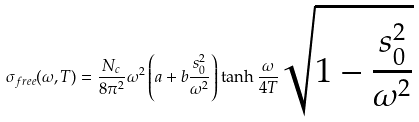<formula> <loc_0><loc_0><loc_500><loc_500>\sigma _ { f r e e } ( \omega , T ) = \frac { N _ { c } } { 8 \pi ^ { 2 } } \omega ^ { 2 } \left ( a + b \frac { s _ { 0 } ^ { 2 } } { \omega ^ { 2 } } \right ) \tanh { \frac { \omega } { 4 T } } \sqrt { 1 - \frac { s _ { 0 } ^ { 2 } } { \omega ^ { 2 } } }</formula> 